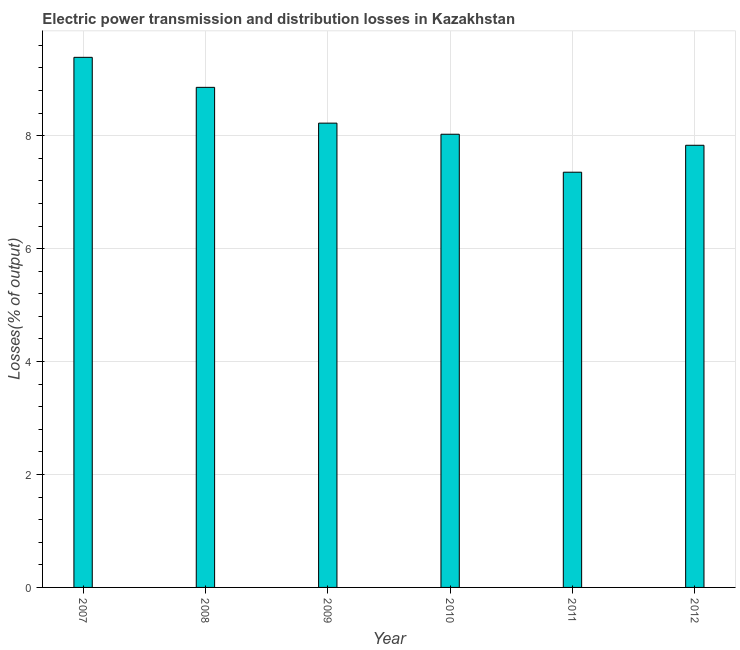Does the graph contain grids?
Give a very brief answer. Yes. What is the title of the graph?
Your answer should be compact. Electric power transmission and distribution losses in Kazakhstan. What is the label or title of the X-axis?
Your response must be concise. Year. What is the label or title of the Y-axis?
Ensure brevity in your answer.  Losses(% of output). What is the electric power transmission and distribution losses in 2008?
Your response must be concise. 8.86. Across all years, what is the maximum electric power transmission and distribution losses?
Offer a terse response. 9.39. Across all years, what is the minimum electric power transmission and distribution losses?
Make the answer very short. 7.35. In which year was the electric power transmission and distribution losses maximum?
Offer a very short reply. 2007. What is the sum of the electric power transmission and distribution losses?
Your response must be concise. 49.68. What is the difference between the electric power transmission and distribution losses in 2009 and 2010?
Provide a short and direct response. 0.2. What is the average electric power transmission and distribution losses per year?
Your answer should be very brief. 8.28. What is the median electric power transmission and distribution losses?
Ensure brevity in your answer.  8.12. In how many years, is the electric power transmission and distribution losses greater than 6.8 %?
Make the answer very short. 6. Is the electric power transmission and distribution losses in 2011 less than that in 2012?
Your answer should be very brief. Yes. Is the difference between the electric power transmission and distribution losses in 2008 and 2010 greater than the difference between any two years?
Your answer should be compact. No. What is the difference between the highest and the second highest electric power transmission and distribution losses?
Keep it short and to the point. 0.53. What is the difference between the highest and the lowest electric power transmission and distribution losses?
Offer a terse response. 2.03. In how many years, is the electric power transmission and distribution losses greater than the average electric power transmission and distribution losses taken over all years?
Ensure brevity in your answer.  2. How many years are there in the graph?
Offer a very short reply. 6. What is the difference between two consecutive major ticks on the Y-axis?
Offer a terse response. 2. Are the values on the major ticks of Y-axis written in scientific E-notation?
Your answer should be very brief. No. What is the Losses(% of output) of 2007?
Offer a very short reply. 9.39. What is the Losses(% of output) of 2008?
Provide a succinct answer. 8.86. What is the Losses(% of output) of 2009?
Offer a terse response. 8.22. What is the Losses(% of output) of 2010?
Keep it short and to the point. 8.03. What is the Losses(% of output) of 2011?
Make the answer very short. 7.35. What is the Losses(% of output) in 2012?
Your answer should be very brief. 7.83. What is the difference between the Losses(% of output) in 2007 and 2008?
Your answer should be compact. 0.53. What is the difference between the Losses(% of output) in 2007 and 2009?
Offer a very short reply. 1.17. What is the difference between the Losses(% of output) in 2007 and 2010?
Offer a very short reply. 1.36. What is the difference between the Losses(% of output) in 2007 and 2011?
Ensure brevity in your answer.  2.03. What is the difference between the Losses(% of output) in 2007 and 2012?
Your answer should be very brief. 1.56. What is the difference between the Losses(% of output) in 2008 and 2009?
Your response must be concise. 0.63. What is the difference between the Losses(% of output) in 2008 and 2010?
Make the answer very short. 0.83. What is the difference between the Losses(% of output) in 2008 and 2011?
Keep it short and to the point. 1.5. What is the difference between the Losses(% of output) in 2008 and 2012?
Your response must be concise. 1.03. What is the difference between the Losses(% of output) in 2009 and 2010?
Provide a succinct answer. 0.2. What is the difference between the Losses(% of output) in 2009 and 2011?
Give a very brief answer. 0.87. What is the difference between the Losses(% of output) in 2009 and 2012?
Make the answer very short. 0.39. What is the difference between the Losses(% of output) in 2010 and 2011?
Offer a very short reply. 0.67. What is the difference between the Losses(% of output) in 2010 and 2012?
Your answer should be compact. 0.2. What is the difference between the Losses(% of output) in 2011 and 2012?
Make the answer very short. -0.48. What is the ratio of the Losses(% of output) in 2007 to that in 2008?
Your response must be concise. 1.06. What is the ratio of the Losses(% of output) in 2007 to that in 2009?
Your answer should be compact. 1.14. What is the ratio of the Losses(% of output) in 2007 to that in 2010?
Keep it short and to the point. 1.17. What is the ratio of the Losses(% of output) in 2007 to that in 2011?
Your answer should be compact. 1.28. What is the ratio of the Losses(% of output) in 2007 to that in 2012?
Your response must be concise. 1.2. What is the ratio of the Losses(% of output) in 2008 to that in 2009?
Your response must be concise. 1.08. What is the ratio of the Losses(% of output) in 2008 to that in 2010?
Provide a succinct answer. 1.1. What is the ratio of the Losses(% of output) in 2008 to that in 2011?
Your answer should be compact. 1.2. What is the ratio of the Losses(% of output) in 2008 to that in 2012?
Provide a short and direct response. 1.13. What is the ratio of the Losses(% of output) in 2009 to that in 2011?
Provide a succinct answer. 1.12. What is the ratio of the Losses(% of output) in 2010 to that in 2011?
Keep it short and to the point. 1.09. What is the ratio of the Losses(% of output) in 2011 to that in 2012?
Provide a short and direct response. 0.94. 